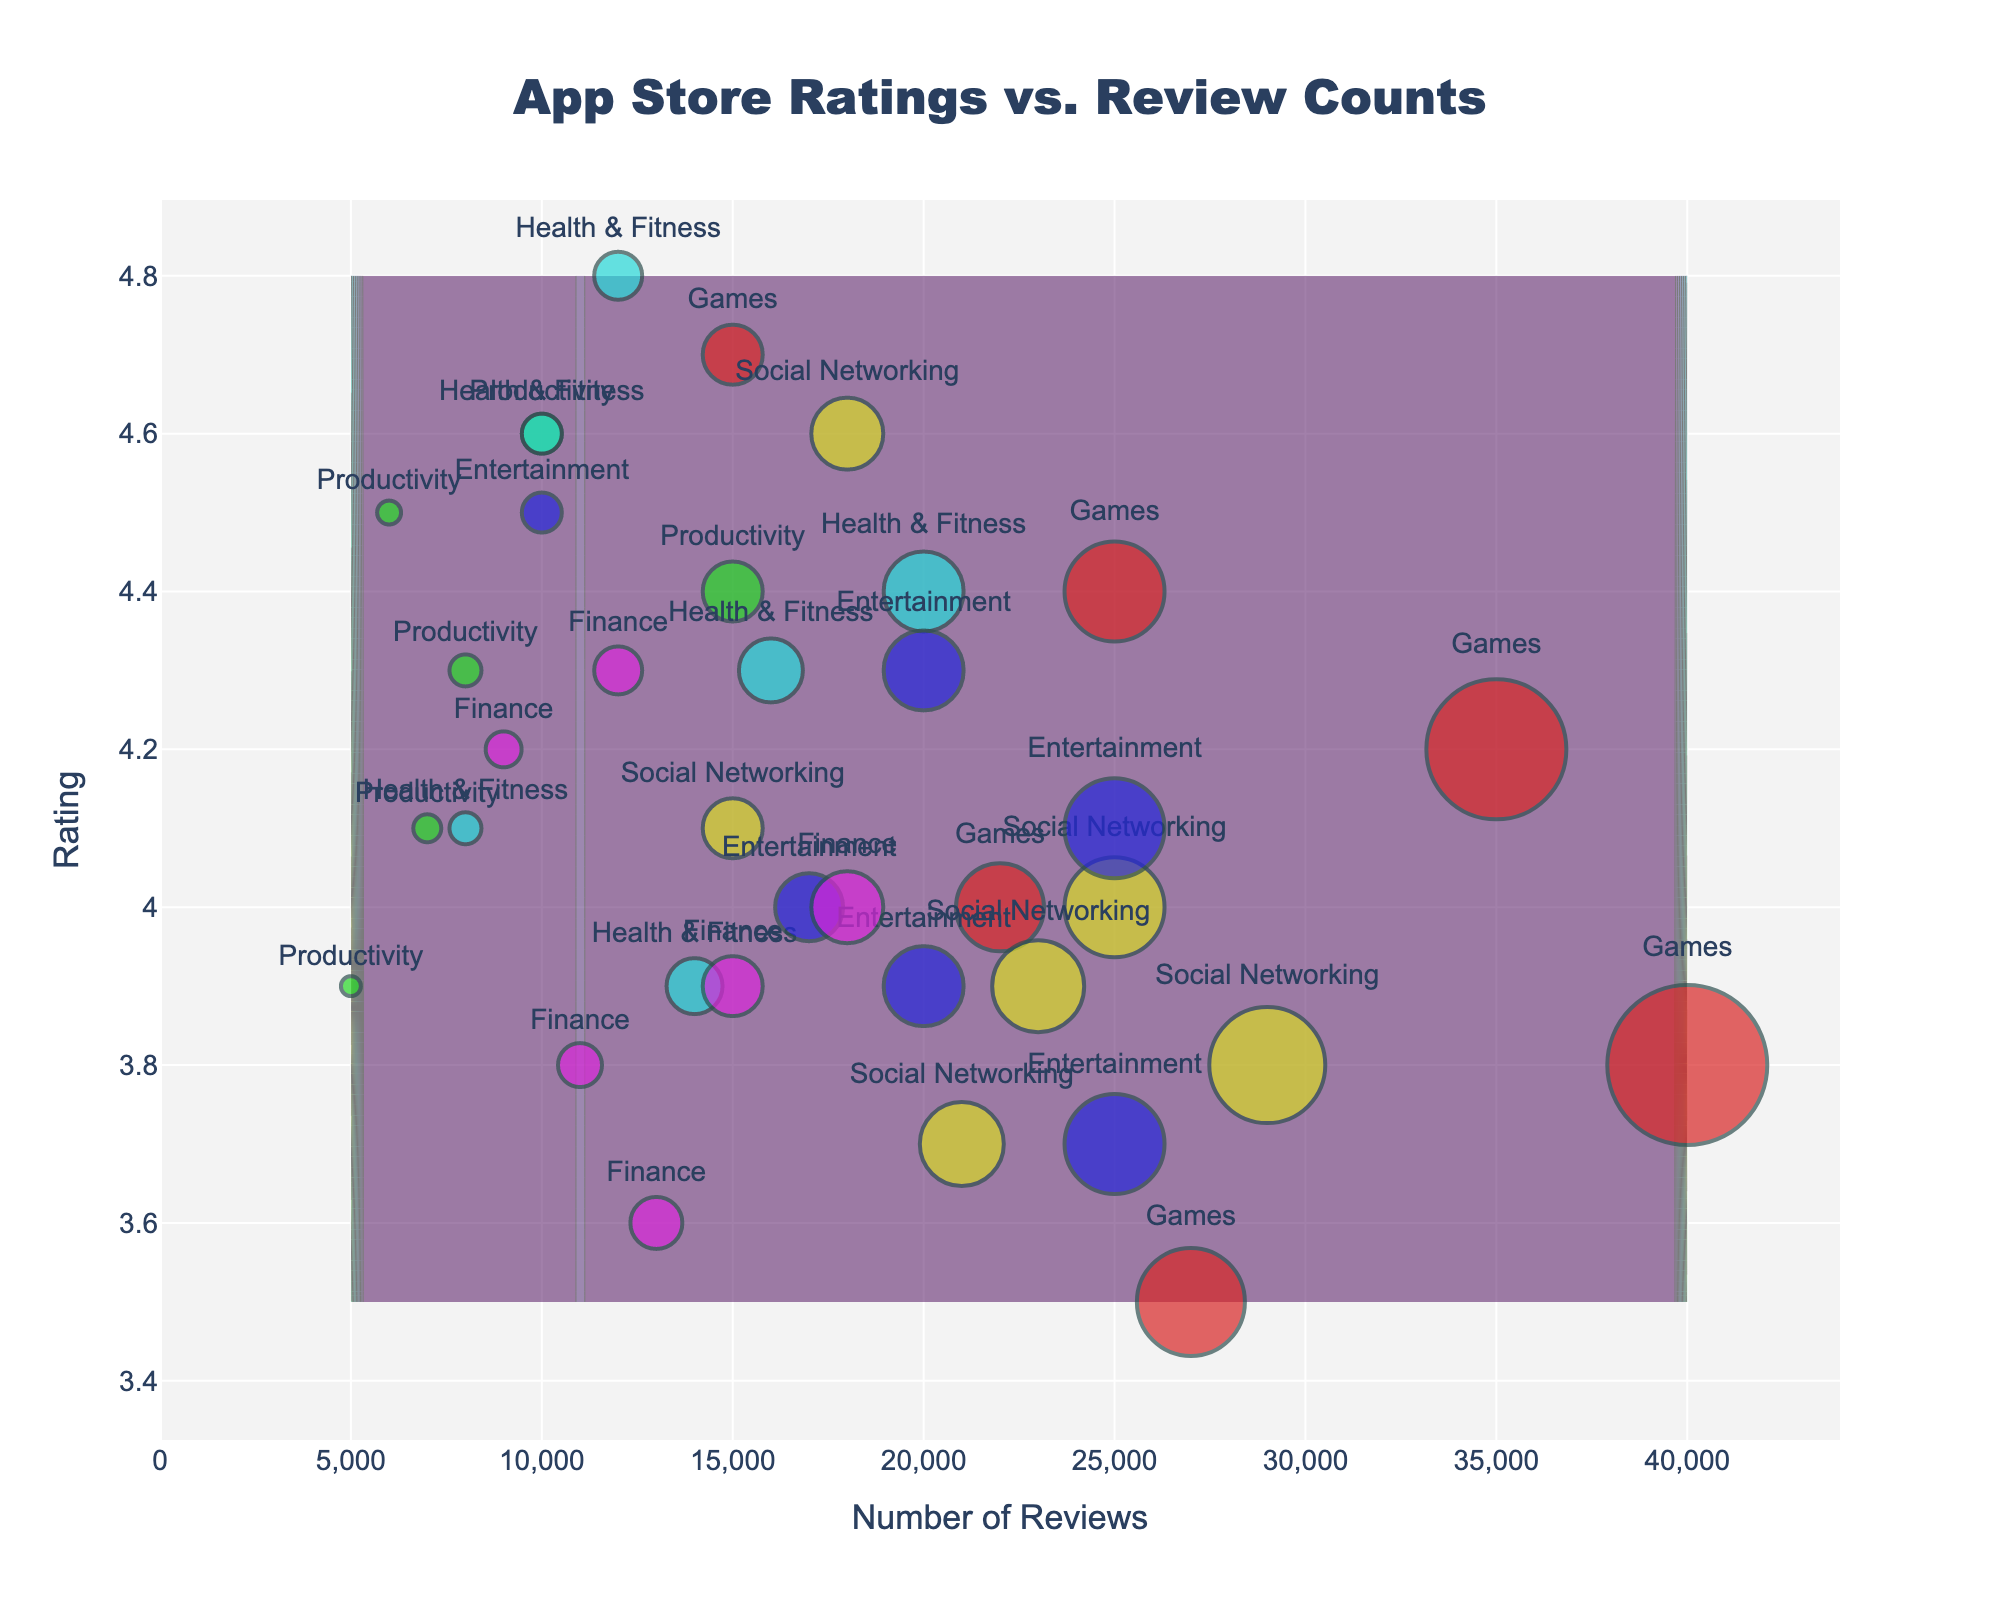What's the title of the plot? The title of the plot is displayed prominently at the top center of the figure.
Answer: App Store Ratings vs. Review Counts What are the x-axis and y-axis labels? The x-axis and y-axis labels are shown adjacent to the respective axes.
Answer: Number of Reviews, Rating Which category has the highest rating? By looking at the markers, identify the highest value on the y-axis and check the label above it.
Answer: Health & Fitness Which category has the highest number of reviews? By finding the category with the data points furthest to the right on the x-axis, you see the maximum number of reviews.
Answer: Games Compare the average ratings of the Games and Productivity categories. Which is higher? Calculate the average of the ratings for each category by adding the ratings and dividing by the number of data points, then compare the results.
Answer: Productivity What is the general trend observed in the contour plot? The contour plot highlights regions of similar density. From the color gradients, you can infer the general correlation between review count and rating.
Answer: Higher review counts often correlate with higher ratings Identify a category that has a lot of reviews but lower average ratings. Look for clusters of markers to the right (high review counts) but lower on the y-axis (lower ratings).
Answer: Finance How many categories have their average ratings above 4.5? Calculate the mean rating for each category and count those which have an average rating above 4.5.
Answer: 2 (Games, Health & Fitness) What does the size of the markers indicate in the plot? Larger markers correspond to a higher number of reviews as per the figure's legend.
Answer: Number of reviews Is there a category that generally has both high ratings and a high number of reviews? Identify categories with both large markers and high y-axis values, which indicates a high number of reviews and high ratings.
Answer: Health & Fitness 